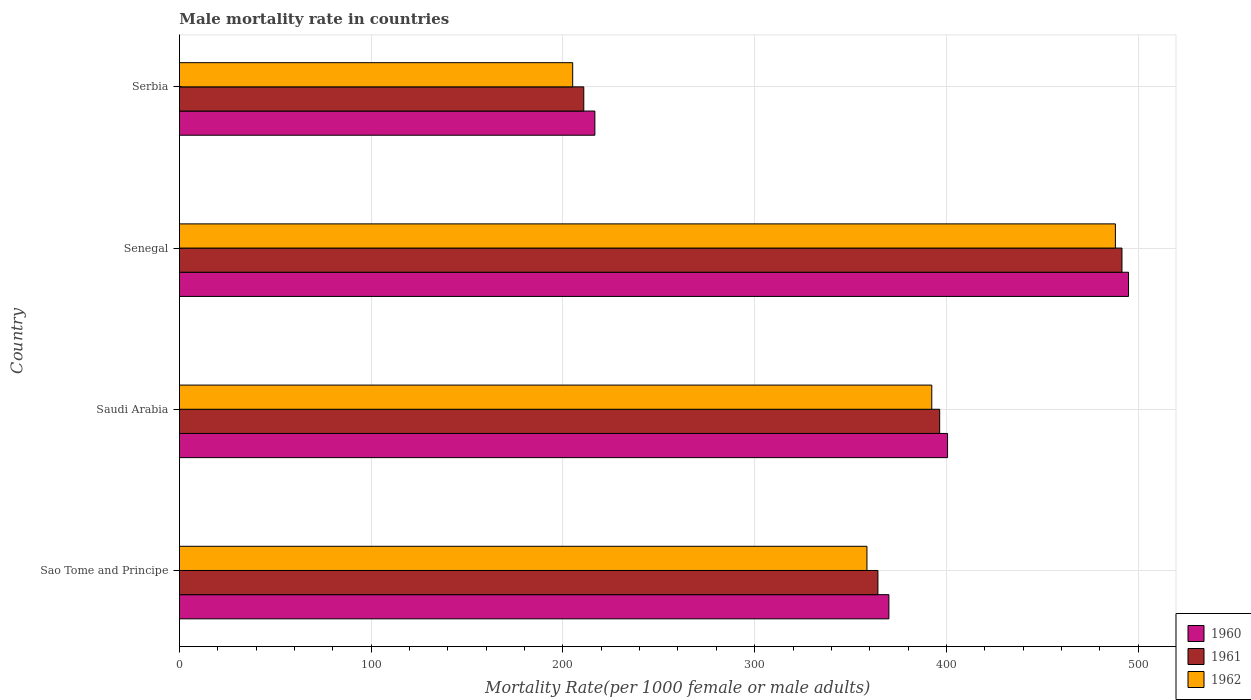How many different coloured bars are there?
Provide a short and direct response. 3. Are the number of bars per tick equal to the number of legend labels?
Your answer should be very brief. Yes. How many bars are there on the 2nd tick from the bottom?
Your response must be concise. 3. What is the label of the 4th group of bars from the top?
Offer a very short reply. Sao Tome and Principe. In how many cases, is the number of bars for a given country not equal to the number of legend labels?
Offer a terse response. 0. What is the male mortality rate in 1962 in Sao Tome and Principe?
Give a very brief answer. 358.54. Across all countries, what is the maximum male mortality rate in 1961?
Your answer should be very brief. 491.53. Across all countries, what is the minimum male mortality rate in 1961?
Give a very brief answer. 210.87. In which country was the male mortality rate in 1960 maximum?
Give a very brief answer. Senegal. In which country was the male mortality rate in 1962 minimum?
Provide a short and direct response. Serbia. What is the total male mortality rate in 1962 in the graph?
Your answer should be compact. 1444.09. What is the difference between the male mortality rate in 1961 in Senegal and that in Serbia?
Keep it short and to the point. 280.66. What is the difference between the male mortality rate in 1960 in Serbia and the male mortality rate in 1962 in Senegal?
Offer a terse response. -271.45. What is the average male mortality rate in 1960 per country?
Offer a very short reply. 370.55. What is the difference between the male mortality rate in 1962 and male mortality rate in 1961 in Sao Tome and Principe?
Provide a short and direct response. -5.72. In how many countries, is the male mortality rate in 1961 greater than 120 ?
Provide a short and direct response. 4. What is the ratio of the male mortality rate in 1962 in Saudi Arabia to that in Senegal?
Offer a very short reply. 0.8. What is the difference between the highest and the second highest male mortality rate in 1961?
Offer a very short reply. 95.06. What is the difference between the highest and the lowest male mortality rate in 1961?
Your answer should be very brief. 280.66. Is the sum of the male mortality rate in 1961 in Senegal and Serbia greater than the maximum male mortality rate in 1960 across all countries?
Keep it short and to the point. Yes. What does the 3rd bar from the bottom in Sao Tome and Principe represents?
Offer a terse response. 1962. How many bars are there?
Offer a terse response. 12. How many countries are there in the graph?
Make the answer very short. 4. Does the graph contain any zero values?
Ensure brevity in your answer.  No. How many legend labels are there?
Give a very brief answer. 3. How are the legend labels stacked?
Offer a terse response. Vertical. What is the title of the graph?
Make the answer very short. Male mortality rate in countries. Does "1971" appear as one of the legend labels in the graph?
Your answer should be compact. No. What is the label or title of the X-axis?
Your answer should be very brief. Mortality Rate(per 1000 female or male adults). What is the Mortality Rate(per 1000 female or male adults) in 1960 in Sao Tome and Principe?
Provide a succinct answer. 369.99. What is the Mortality Rate(per 1000 female or male adults) of 1961 in Sao Tome and Principe?
Provide a short and direct response. 364.26. What is the Mortality Rate(per 1000 female or male adults) in 1962 in Sao Tome and Principe?
Provide a succinct answer. 358.54. What is the Mortality Rate(per 1000 female or male adults) in 1960 in Saudi Arabia?
Offer a terse response. 400.58. What is the Mortality Rate(per 1000 female or male adults) of 1961 in Saudi Arabia?
Your response must be concise. 396.47. What is the Mortality Rate(per 1000 female or male adults) in 1962 in Saudi Arabia?
Provide a short and direct response. 392.35. What is the Mortality Rate(per 1000 female or male adults) in 1960 in Senegal?
Make the answer very short. 494.96. What is the Mortality Rate(per 1000 female or male adults) of 1961 in Senegal?
Provide a succinct answer. 491.53. What is the Mortality Rate(per 1000 female or male adults) of 1962 in Senegal?
Offer a very short reply. 488.11. What is the Mortality Rate(per 1000 female or male adults) in 1960 in Serbia?
Keep it short and to the point. 216.66. What is the Mortality Rate(per 1000 female or male adults) of 1961 in Serbia?
Provide a short and direct response. 210.87. What is the Mortality Rate(per 1000 female or male adults) in 1962 in Serbia?
Give a very brief answer. 205.09. Across all countries, what is the maximum Mortality Rate(per 1000 female or male adults) of 1960?
Your answer should be very brief. 494.96. Across all countries, what is the maximum Mortality Rate(per 1000 female or male adults) in 1961?
Offer a terse response. 491.53. Across all countries, what is the maximum Mortality Rate(per 1000 female or male adults) of 1962?
Provide a short and direct response. 488.11. Across all countries, what is the minimum Mortality Rate(per 1000 female or male adults) of 1960?
Your answer should be very brief. 216.66. Across all countries, what is the minimum Mortality Rate(per 1000 female or male adults) of 1961?
Your response must be concise. 210.87. Across all countries, what is the minimum Mortality Rate(per 1000 female or male adults) of 1962?
Offer a terse response. 205.09. What is the total Mortality Rate(per 1000 female or male adults) in 1960 in the graph?
Give a very brief answer. 1482.18. What is the total Mortality Rate(per 1000 female or male adults) of 1961 in the graph?
Provide a succinct answer. 1463.14. What is the total Mortality Rate(per 1000 female or male adults) of 1962 in the graph?
Make the answer very short. 1444.09. What is the difference between the Mortality Rate(per 1000 female or male adults) of 1960 in Sao Tome and Principe and that in Saudi Arabia?
Give a very brief answer. -30.59. What is the difference between the Mortality Rate(per 1000 female or male adults) in 1961 in Sao Tome and Principe and that in Saudi Arabia?
Offer a very short reply. -32.2. What is the difference between the Mortality Rate(per 1000 female or male adults) in 1962 in Sao Tome and Principe and that in Saudi Arabia?
Provide a short and direct response. -33.81. What is the difference between the Mortality Rate(per 1000 female or male adults) of 1960 in Sao Tome and Principe and that in Senegal?
Offer a terse response. -124.97. What is the difference between the Mortality Rate(per 1000 female or male adults) of 1961 in Sao Tome and Principe and that in Senegal?
Offer a very short reply. -127.27. What is the difference between the Mortality Rate(per 1000 female or male adults) in 1962 in Sao Tome and Principe and that in Senegal?
Offer a very short reply. -129.56. What is the difference between the Mortality Rate(per 1000 female or male adults) in 1960 in Sao Tome and Principe and that in Serbia?
Give a very brief answer. 153.33. What is the difference between the Mortality Rate(per 1000 female or male adults) in 1961 in Sao Tome and Principe and that in Serbia?
Provide a short and direct response. 153.39. What is the difference between the Mortality Rate(per 1000 female or male adults) of 1962 in Sao Tome and Principe and that in Serbia?
Offer a terse response. 153.45. What is the difference between the Mortality Rate(per 1000 female or male adults) of 1960 in Saudi Arabia and that in Senegal?
Your response must be concise. -94.38. What is the difference between the Mortality Rate(per 1000 female or male adults) of 1961 in Saudi Arabia and that in Senegal?
Ensure brevity in your answer.  -95.06. What is the difference between the Mortality Rate(per 1000 female or male adults) of 1962 in Saudi Arabia and that in Senegal?
Offer a terse response. -95.75. What is the difference between the Mortality Rate(per 1000 female or male adults) in 1960 in Saudi Arabia and that in Serbia?
Ensure brevity in your answer.  183.92. What is the difference between the Mortality Rate(per 1000 female or male adults) in 1961 in Saudi Arabia and that in Serbia?
Your answer should be very brief. 185.59. What is the difference between the Mortality Rate(per 1000 female or male adults) in 1962 in Saudi Arabia and that in Serbia?
Give a very brief answer. 187.26. What is the difference between the Mortality Rate(per 1000 female or male adults) of 1960 in Senegal and that in Serbia?
Give a very brief answer. 278.3. What is the difference between the Mortality Rate(per 1000 female or male adults) of 1961 in Senegal and that in Serbia?
Your answer should be compact. 280.66. What is the difference between the Mortality Rate(per 1000 female or male adults) of 1962 in Senegal and that in Serbia?
Provide a succinct answer. 283.02. What is the difference between the Mortality Rate(per 1000 female or male adults) in 1960 in Sao Tome and Principe and the Mortality Rate(per 1000 female or male adults) in 1961 in Saudi Arabia?
Give a very brief answer. -26.48. What is the difference between the Mortality Rate(per 1000 female or male adults) of 1960 in Sao Tome and Principe and the Mortality Rate(per 1000 female or male adults) of 1962 in Saudi Arabia?
Provide a succinct answer. -22.36. What is the difference between the Mortality Rate(per 1000 female or male adults) of 1961 in Sao Tome and Principe and the Mortality Rate(per 1000 female or male adults) of 1962 in Saudi Arabia?
Offer a terse response. -28.09. What is the difference between the Mortality Rate(per 1000 female or male adults) of 1960 in Sao Tome and Principe and the Mortality Rate(per 1000 female or male adults) of 1961 in Senegal?
Make the answer very short. -121.55. What is the difference between the Mortality Rate(per 1000 female or male adults) of 1960 in Sao Tome and Principe and the Mortality Rate(per 1000 female or male adults) of 1962 in Senegal?
Ensure brevity in your answer.  -118.12. What is the difference between the Mortality Rate(per 1000 female or male adults) of 1961 in Sao Tome and Principe and the Mortality Rate(per 1000 female or male adults) of 1962 in Senegal?
Your answer should be very brief. -123.84. What is the difference between the Mortality Rate(per 1000 female or male adults) in 1960 in Sao Tome and Principe and the Mortality Rate(per 1000 female or male adults) in 1961 in Serbia?
Make the answer very short. 159.11. What is the difference between the Mortality Rate(per 1000 female or male adults) of 1960 in Sao Tome and Principe and the Mortality Rate(per 1000 female or male adults) of 1962 in Serbia?
Offer a very short reply. 164.9. What is the difference between the Mortality Rate(per 1000 female or male adults) of 1961 in Sao Tome and Principe and the Mortality Rate(per 1000 female or male adults) of 1962 in Serbia?
Keep it short and to the point. 159.18. What is the difference between the Mortality Rate(per 1000 female or male adults) of 1960 in Saudi Arabia and the Mortality Rate(per 1000 female or male adults) of 1961 in Senegal?
Your response must be concise. -90.95. What is the difference between the Mortality Rate(per 1000 female or male adults) of 1960 in Saudi Arabia and the Mortality Rate(per 1000 female or male adults) of 1962 in Senegal?
Your answer should be very brief. -87.53. What is the difference between the Mortality Rate(per 1000 female or male adults) of 1961 in Saudi Arabia and the Mortality Rate(per 1000 female or male adults) of 1962 in Senegal?
Provide a short and direct response. -91.64. What is the difference between the Mortality Rate(per 1000 female or male adults) of 1960 in Saudi Arabia and the Mortality Rate(per 1000 female or male adults) of 1961 in Serbia?
Provide a short and direct response. 189.71. What is the difference between the Mortality Rate(per 1000 female or male adults) in 1960 in Saudi Arabia and the Mortality Rate(per 1000 female or male adults) in 1962 in Serbia?
Your answer should be compact. 195.49. What is the difference between the Mortality Rate(per 1000 female or male adults) of 1961 in Saudi Arabia and the Mortality Rate(per 1000 female or male adults) of 1962 in Serbia?
Give a very brief answer. 191.38. What is the difference between the Mortality Rate(per 1000 female or male adults) in 1960 in Senegal and the Mortality Rate(per 1000 female or male adults) in 1961 in Serbia?
Provide a short and direct response. 284.08. What is the difference between the Mortality Rate(per 1000 female or male adults) of 1960 in Senegal and the Mortality Rate(per 1000 female or male adults) of 1962 in Serbia?
Give a very brief answer. 289.87. What is the difference between the Mortality Rate(per 1000 female or male adults) in 1961 in Senegal and the Mortality Rate(per 1000 female or male adults) in 1962 in Serbia?
Offer a very short reply. 286.44. What is the average Mortality Rate(per 1000 female or male adults) of 1960 per country?
Provide a succinct answer. 370.55. What is the average Mortality Rate(per 1000 female or male adults) in 1961 per country?
Your answer should be very brief. 365.78. What is the average Mortality Rate(per 1000 female or male adults) in 1962 per country?
Offer a terse response. 361.02. What is the difference between the Mortality Rate(per 1000 female or male adults) in 1960 and Mortality Rate(per 1000 female or male adults) in 1961 in Sao Tome and Principe?
Offer a terse response. 5.72. What is the difference between the Mortality Rate(per 1000 female or male adults) of 1960 and Mortality Rate(per 1000 female or male adults) of 1962 in Sao Tome and Principe?
Your response must be concise. 11.44. What is the difference between the Mortality Rate(per 1000 female or male adults) in 1961 and Mortality Rate(per 1000 female or male adults) in 1962 in Sao Tome and Principe?
Give a very brief answer. 5.72. What is the difference between the Mortality Rate(per 1000 female or male adults) of 1960 and Mortality Rate(per 1000 female or male adults) of 1961 in Saudi Arabia?
Provide a succinct answer. 4.11. What is the difference between the Mortality Rate(per 1000 female or male adults) in 1960 and Mortality Rate(per 1000 female or male adults) in 1962 in Saudi Arabia?
Keep it short and to the point. 8.23. What is the difference between the Mortality Rate(per 1000 female or male adults) of 1961 and Mortality Rate(per 1000 female or male adults) of 1962 in Saudi Arabia?
Your answer should be very brief. 4.12. What is the difference between the Mortality Rate(per 1000 female or male adults) of 1960 and Mortality Rate(per 1000 female or male adults) of 1961 in Senegal?
Ensure brevity in your answer.  3.43. What is the difference between the Mortality Rate(per 1000 female or male adults) of 1960 and Mortality Rate(per 1000 female or male adults) of 1962 in Senegal?
Provide a short and direct response. 6.85. What is the difference between the Mortality Rate(per 1000 female or male adults) in 1961 and Mortality Rate(per 1000 female or male adults) in 1962 in Senegal?
Offer a very short reply. 3.43. What is the difference between the Mortality Rate(per 1000 female or male adults) of 1960 and Mortality Rate(per 1000 female or male adults) of 1961 in Serbia?
Keep it short and to the point. 5.78. What is the difference between the Mortality Rate(per 1000 female or male adults) of 1960 and Mortality Rate(per 1000 female or male adults) of 1962 in Serbia?
Make the answer very short. 11.57. What is the difference between the Mortality Rate(per 1000 female or male adults) of 1961 and Mortality Rate(per 1000 female or male adults) of 1962 in Serbia?
Your response must be concise. 5.78. What is the ratio of the Mortality Rate(per 1000 female or male adults) in 1960 in Sao Tome and Principe to that in Saudi Arabia?
Ensure brevity in your answer.  0.92. What is the ratio of the Mortality Rate(per 1000 female or male adults) in 1961 in Sao Tome and Principe to that in Saudi Arabia?
Your answer should be very brief. 0.92. What is the ratio of the Mortality Rate(per 1000 female or male adults) of 1962 in Sao Tome and Principe to that in Saudi Arabia?
Ensure brevity in your answer.  0.91. What is the ratio of the Mortality Rate(per 1000 female or male adults) of 1960 in Sao Tome and Principe to that in Senegal?
Ensure brevity in your answer.  0.75. What is the ratio of the Mortality Rate(per 1000 female or male adults) of 1961 in Sao Tome and Principe to that in Senegal?
Your answer should be compact. 0.74. What is the ratio of the Mortality Rate(per 1000 female or male adults) of 1962 in Sao Tome and Principe to that in Senegal?
Keep it short and to the point. 0.73. What is the ratio of the Mortality Rate(per 1000 female or male adults) in 1960 in Sao Tome and Principe to that in Serbia?
Your answer should be very brief. 1.71. What is the ratio of the Mortality Rate(per 1000 female or male adults) in 1961 in Sao Tome and Principe to that in Serbia?
Provide a succinct answer. 1.73. What is the ratio of the Mortality Rate(per 1000 female or male adults) of 1962 in Sao Tome and Principe to that in Serbia?
Give a very brief answer. 1.75. What is the ratio of the Mortality Rate(per 1000 female or male adults) of 1960 in Saudi Arabia to that in Senegal?
Make the answer very short. 0.81. What is the ratio of the Mortality Rate(per 1000 female or male adults) of 1961 in Saudi Arabia to that in Senegal?
Your answer should be compact. 0.81. What is the ratio of the Mortality Rate(per 1000 female or male adults) of 1962 in Saudi Arabia to that in Senegal?
Offer a very short reply. 0.8. What is the ratio of the Mortality Rate(per 1000 female or male adults) of 1960 in Saudi Arabia to that in Serbia?
Provide a short and direct response. 1.85. What is the ratio of the Mortality Rate(per 1000 female or male adults) in 1961 in Saudi Arabia to that in Serbia?
Offer a terse response. 1.88. What is the ratio of the Mortality Rate(per 1000 female or male adults) of 1962 in Saudi Arabia to that in Serbia?
Your answer should be very brief. 1.91. What is the ratio of the Mortality Rate(per 1000 female or male adults) in 1960 in Senegal to that in Serbia?
Your answer should be compact. 2.28. What is the ratio of the Mortality Rate(per 1000 female or male adults) in 1961 in Senegal to that in Serbia?
Offer a terse response. 2.33. What is the ratio of the Mortality Rate(per 1000 female or male adults) of 1962 in Senegal to that in Serbia?
Give a very brief answer. 2.38. What is the difference between the highest and the second highest Mortality Rate(per 1000 female or male adults) in 1960?
Make the answer very short. 94.38. What is the difference between the highest and the second highest Mortality Rate(per 1000 female or male adults) in 1961?
Your answer should be compact. 95.06. What is the difference between the highest and the second highest Mortality Rate(per 1000 female or male adults) of 1962?
Make the answer very short. 95.75. What is the difference between the highest and the lowest Mortality Rate(per 1000 female or male adults) of 1960?
Ensure brevity in your answer.  278.3. What is the difference between the highest and the lowest Mortality Rate(per 1000 female or male adults) in 1961?
Ensure brevity in your answer.  280.66. What is the difference between the highest and the lowest Mortality Rate(per 1000 female or male adults) in 1962?
Offer a very short reply. 283.02. 